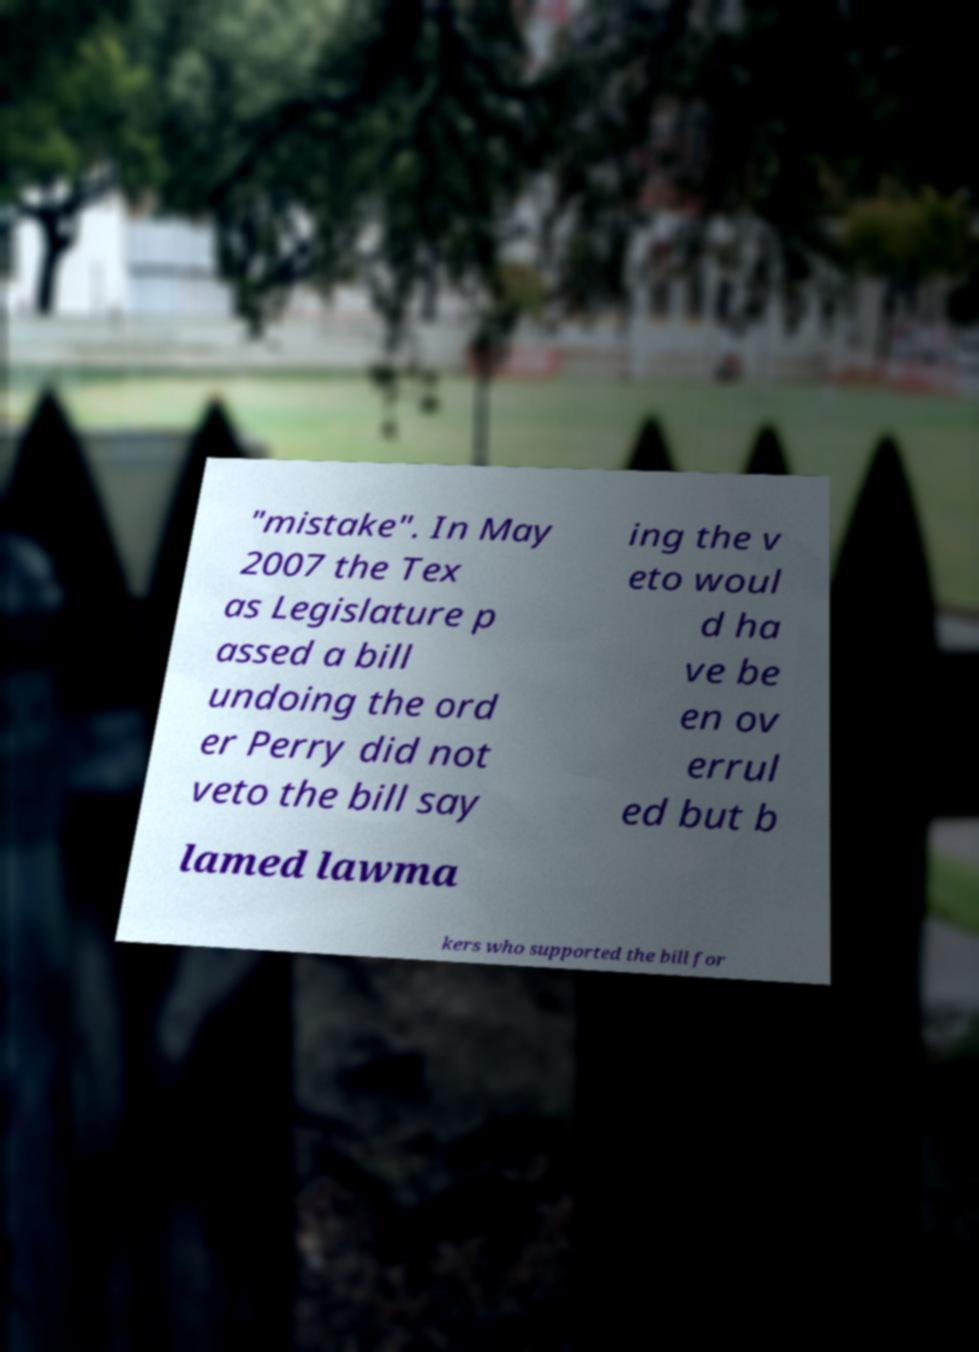Could you assist in decoding the text presented in this image and type it out clearly? "mistake". In May 2007 the Tex as Legislature p assed a bill undoing the ord er Perry did not veto the bill say ing the v eto woul d ha ve be en ov errul ed but b lamed lawma kers who supported the bill for 